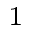<formula> <loc_0><loc_0><loc_500><loc_500>^ { 1 }</formula> 